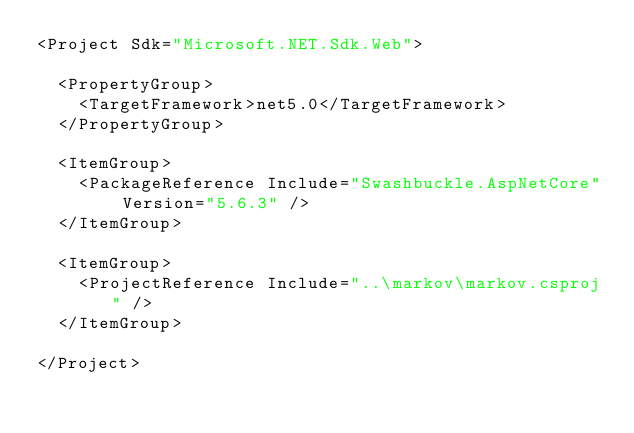<code> <loc_0><loc_0><loc_500><loc_500><_XML_><Project Sdk="Microsoft.NET.Sdk.Web">

  <PropertyGroup>
    <TargetFramework>net5.0</TargetFramework>
  </PropertyGroup>

  <ItemGroup>
    <PackageReference Include="Swashbuckle.AspNetCore" Version="5.6.3" />
  </ItemGroup>

  <ItemGroup>
    <ProjectReference Include="..\markov\markov.csproj" />
  </ItemGroup>

</Project>
</code> 